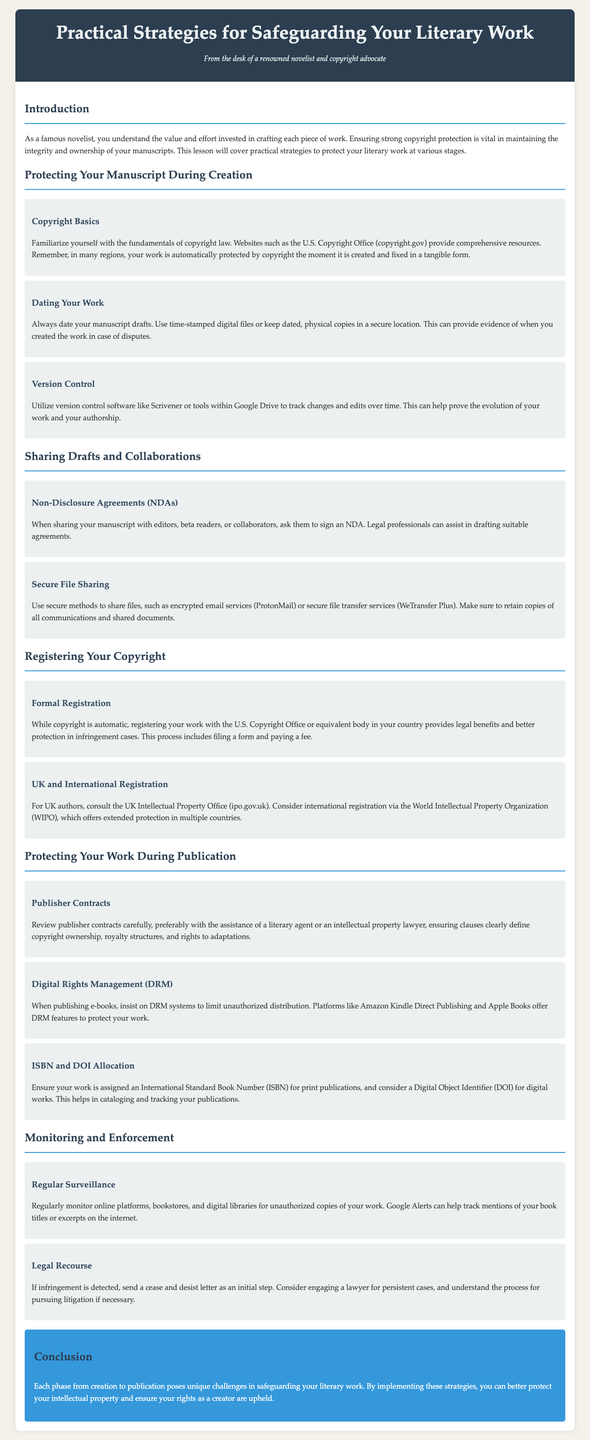What is the title of the lesson plan? The title is prominently displayed at the top of the document and is "Practical Strategies for Safeguarding Your Literary Work."
Answer: Practical Strategies for Safeguarding Your Literary Work What is the main focus of the lesson plan? The introductory section outlines the purpose, which is to cover practical strategies to protect literary work at various stages.
Answer: Protect literary work Which organization provides resources on copyright basics? The document mentions a specific resource for understanding copyright, which is the U.S. Copyright Office.
Answer: U.S. Copyright Office What type of agreements should be signed when sharing drafts? In the section about sharing drafts, it is mentioned that Non-Disclosure Agreements (NDAs) should be signed.
Answer: Non-Disclosure Agreements (NDAs) What should you ensure is assigned for print publications? The section on protecting work during publication highlights the need for an International Standard Book Number (ISBN).
Answer: International Standard Book Number (ISBN) How can you monitor for unauthorized copies of your work? The document suggests using Google Alerts to track mentions of book titles or excerpts online.
Answer: Google Alerts What initial step should you take if infringement is detected? The monitoring and enforcement section outlines that a cease and desist letter is the first step in case of infringement.
Answer: Cease and desist letter What is a benefit of formal registration of copyrights? The document states that registering your work offers legal benefits and better protection in infringement cases.
Answer: Legal benefits Why is version control important for authors? The section on protecting manuscripts explains that version control helps prove the evolution of your work and authorship.
Answer: Prove authorship 